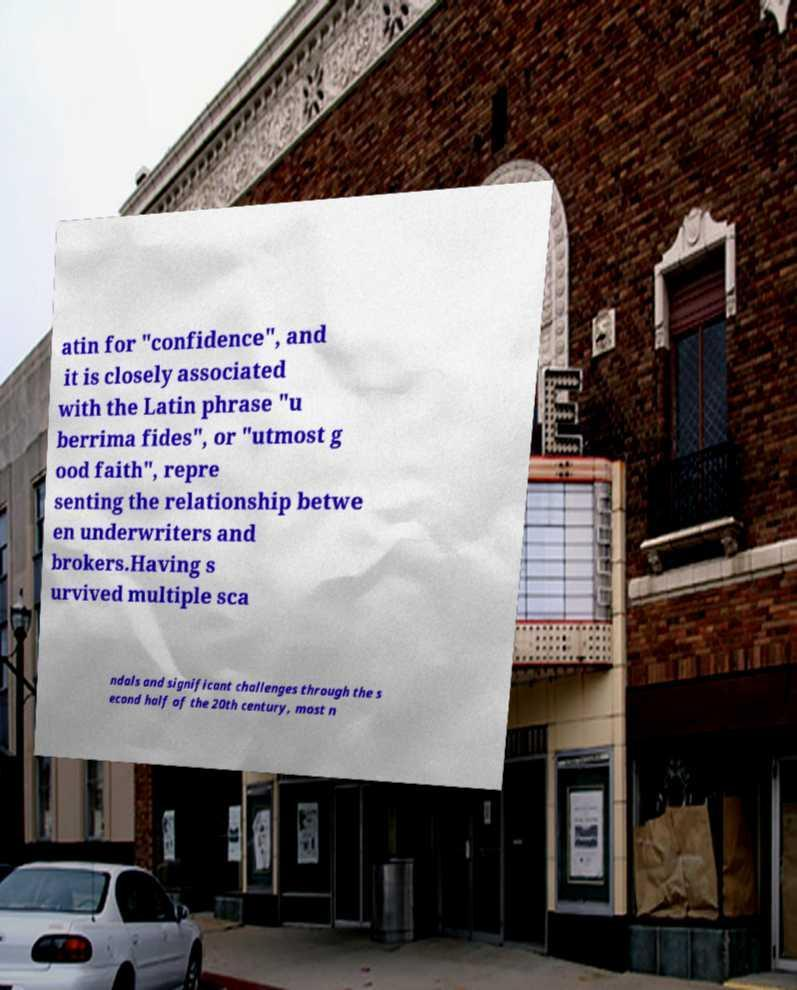For documentation purposes, I need the text within this image transcribed. Could you provide that? atin for "confidence", and it is closely associated with the Latin phrase "u berrima fides", or "utmost g ood faith", repre senting the relationship betwe en underwriters and brokers.Having s urvived multiple sca ndals and significant challenges through the s econd half of the 20th century, most n 